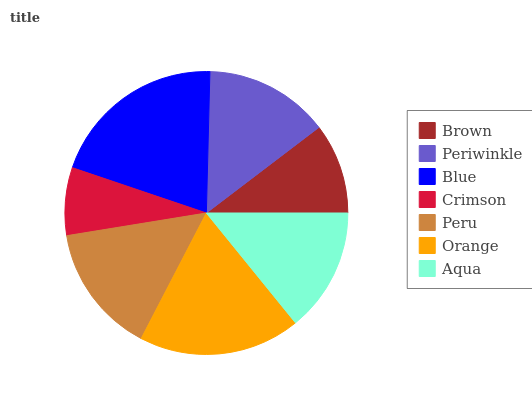Is Crimson the minimum?
Answer yes or no. Yes. Is Blue the maximum?
Answer yes or no. Yes. Is Periwinkle the minimum?
Answer yes or no. No. Is Periwinkle the maximum?
Answer yes or no. No. Is Periwinkle greater than Brown?
Answer yes or no. Yes. Is Brown less than Periwinkle?
Answer yes or no. Yes. Is Brown greater than Periwinkle?
Answer yes or no. No. Is Periwinkle less than Brown?
Answer yes or no. No. Is Periwinkle the high median?
Answer yes or no. Yes. Is Periwinkle the low median?
Answer yes or no. Yes. Is Aqua the high median?
Answer yes or no. No. Is Peru the low median?
Answer yes or no. No. 